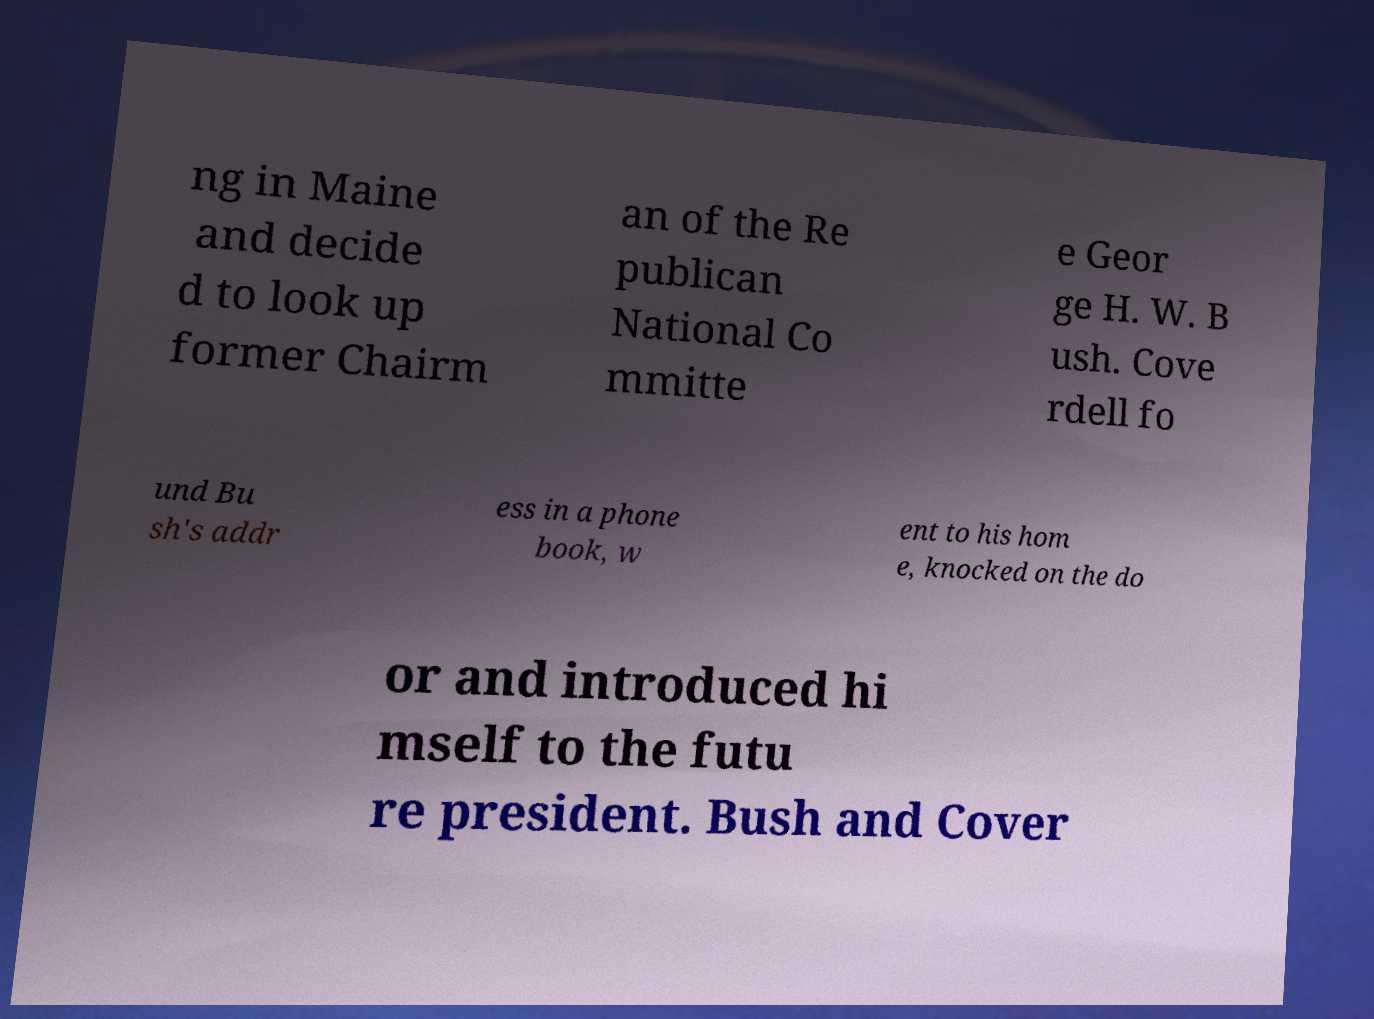Please identify and transcribe the text found in this image. ng in Maine and decide d to look up former Chairm an of the Re publican National Co mmitte e Geor ge H. W. B ush. Cove rdell fo und Bu sh's addr ess in a phone book, w ent to his hom e, knocked on the do or and introduced hi mself to the futu re president. Bush and Cover 